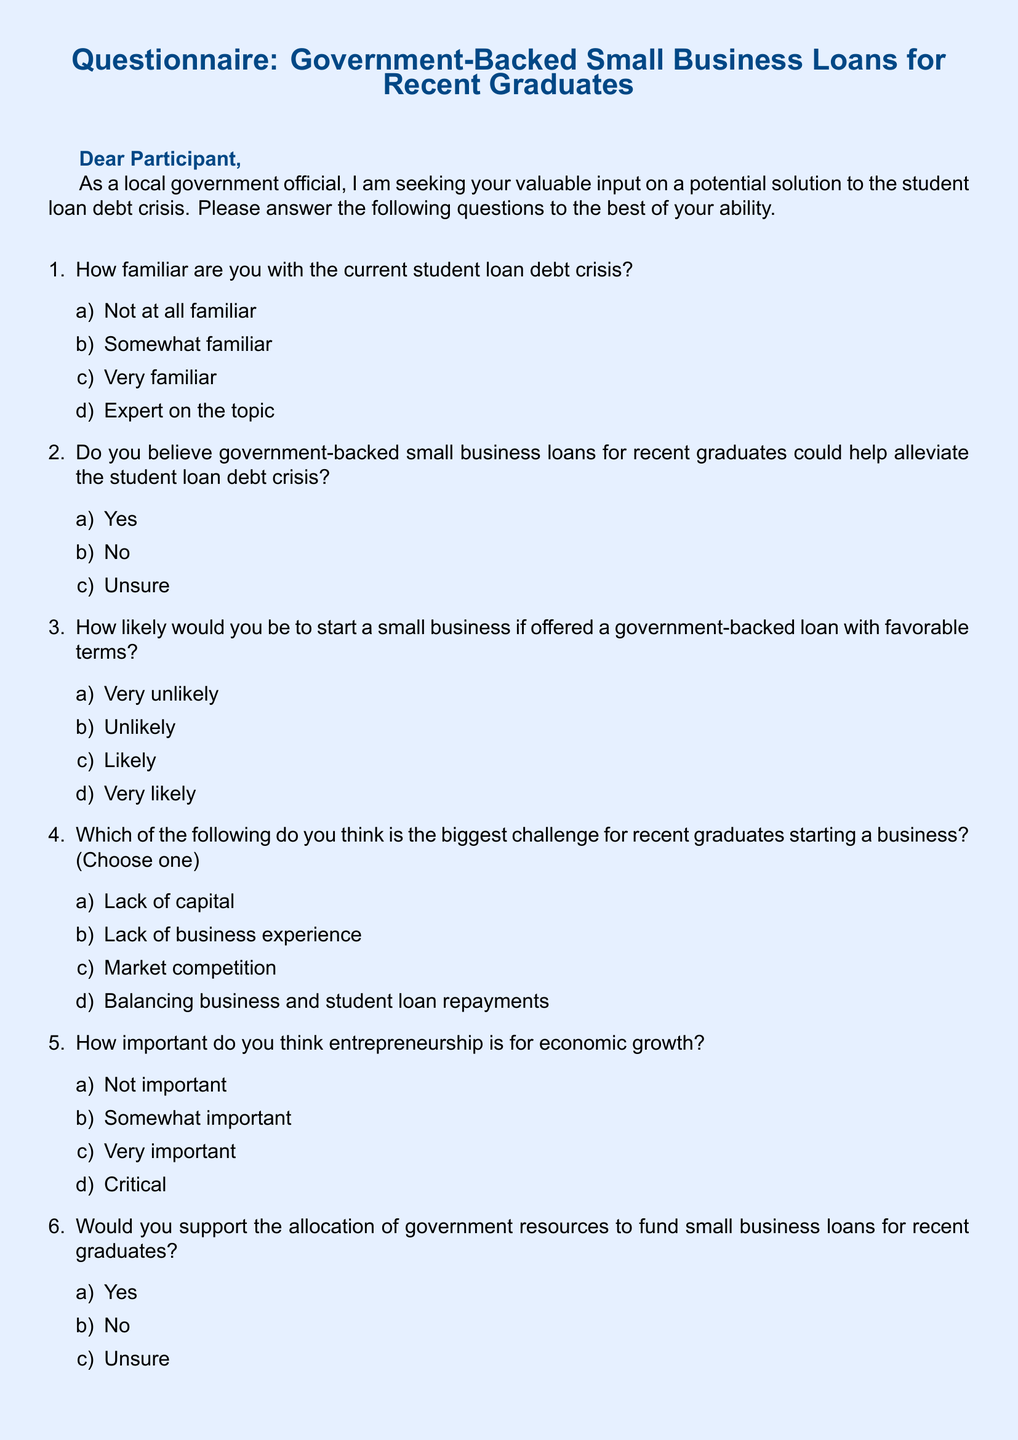What is the title of the document? The title is presented at the top of the document in a large font.
Answer: Questionnaire: Government-Backed Small Business Loans for Recent Graduates What color is used for the document header? The header color is specified in the document to create a distinct look.
Answer: govblue How many questions are included in the questionnaire? The total number of questions can be counted in the enumerated list provided.
Answer: Eight What is the first option for question 1 regarding familiarity with the student loan debt crisis? The options for familiarity are listed as part of the first question.
Answer: Not at all familiar What additional support is suggested for recent graduates in question 7? The support options are listed as selections for the participants to choose from.
Answer: Mentorship programs, Business skills training, Networking opportunities, Incubator/accelerator programs What term describes the government-backed loans intended for recent graduates? The loans are characterized in the introduction of the questionnaire.
Answer: Government-backed How does the questionnaire solicit participant opinions on community impact? The impact question is structured to gauge perceptions on the local community.
Answer: How do you think a program offering government-backed small business loans to recent graduates would impact your local community? What is the coloration of the page background in the document? The background color is set to create an inviting look for the questionnaire.
Answer: lightblue 